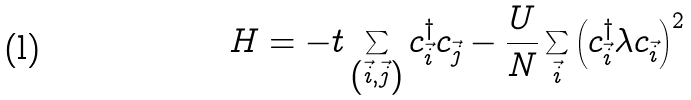Convert formula to latex. <formula><loc_0><loc_0><loc_500><loc_500>H = - t \sum _ { \left ( \vec { i } , \vec { j } \right ) } { c } ^ { \dagger } _ { \vec { i } } { c } _ { \vec { j } } - \frac { U } { N } \sum _ { \vec { i } } \left ( { c } ^ { \dagger } _ { \vec { i } } { \lambda } { c } _ { \vec { i } } \right ) ^ { 2 }</formula> 